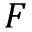<formula> <loc_0><loc_0><loc_500><loc_500>F</formula> 